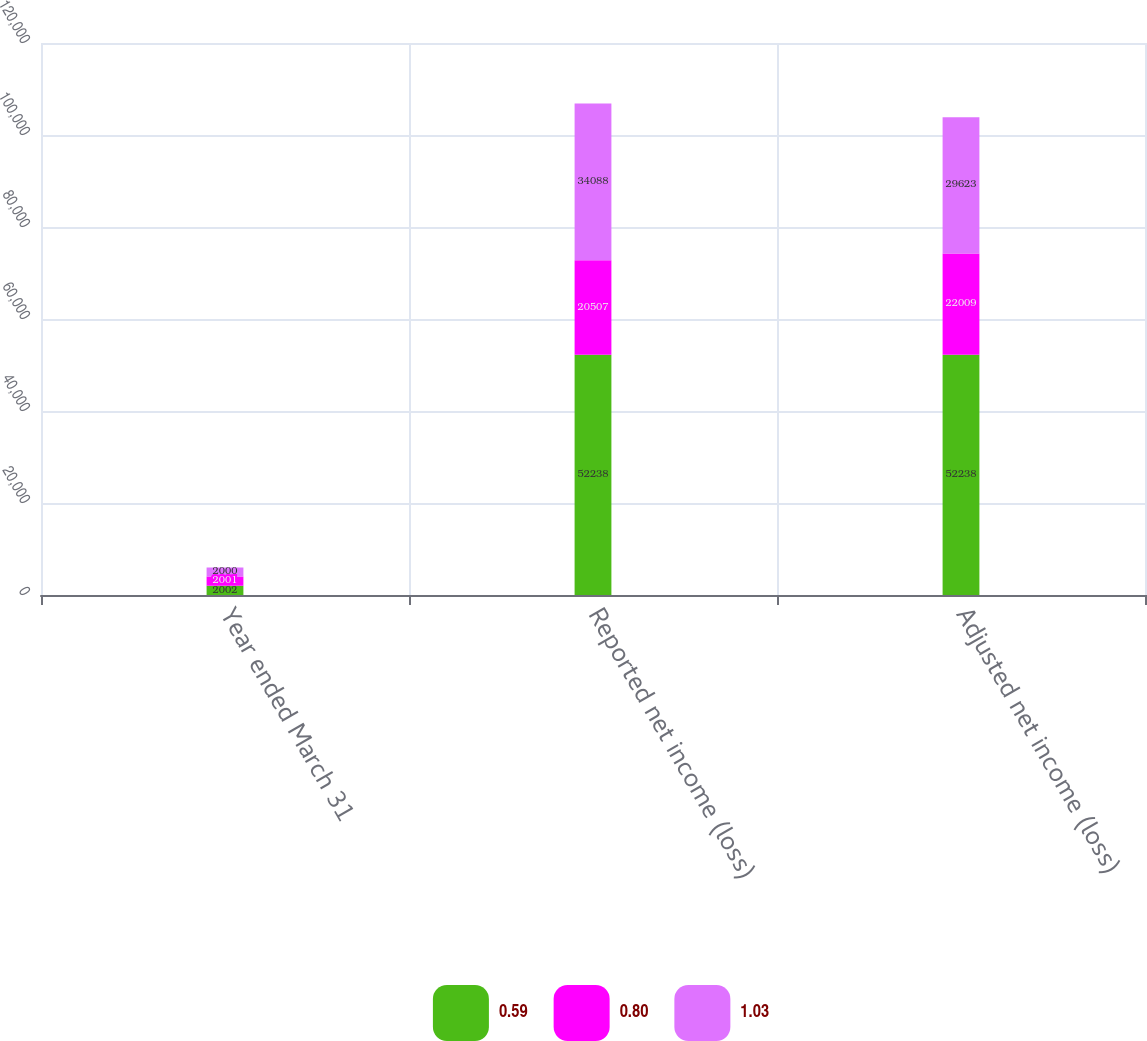Convert chart. <chart><loc_0><loc_0><loc_500><loc_500><stacked_bar_chart><ecel><fcel>Year ended March 31<fcel>Reported net income (loss)<fcel>Adjusted net income (loss)<nl><fcel>0.59<fcel>2002<fcel>52238<fcel>52238<nl><fcel>0.8<fcel>2001<fcel>20507<fcel>22009<nl><fcel>1.03<fcel>2000<fcel>34088<fcel>29623<nl></chart> 